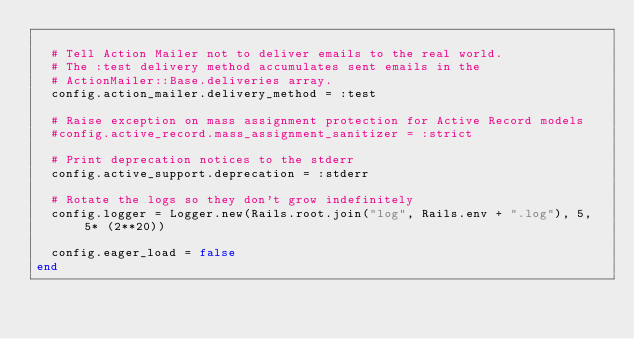<code> <loc_0><loc_0><loc_500><loc_500><_Ruby_>
  # Tell Action Mailer not to deliver emails to the real world.
  # The :test delivery method accumulates sent emails in the
  # ActionMailer::Base.deliveries array.
  config.action_mailer.delivery_method = :test

  # Raise exception on mass assignment protection for Active Record models
  #config.active_record.mass_assignment_sanitizer = :strict

  # Print deprecation notices to the stderr
  config.active_support.deprecation = :stderr

  # Rotate the logs so they don't grow indefinitely
  config.logger = Logger.new(Rails.root.join("log", Rails.env + ".log"), 5, 5* (2**20))

  config.eager_load = false
end
</code> 